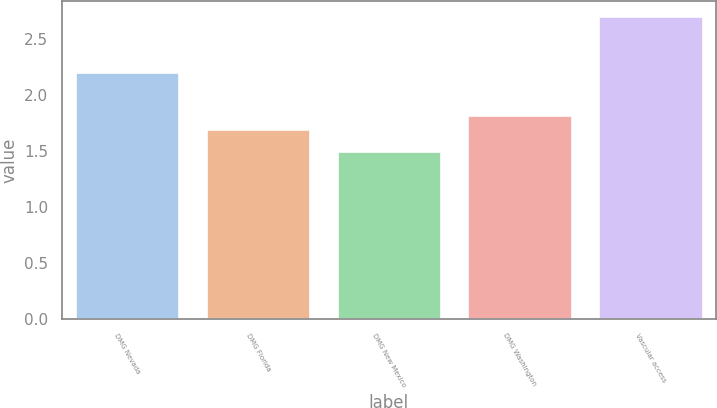<chart> <loc_0><loc_0><loc_500><loc_500><bar_chart><fcel>DMG Nevada<fcel>DMG Florida<fcel>DMG New Mexico<fcel>DMG Washington<fcel>Vascular access<nl><fcel>2.2<fcel>1.7<fcel>1.5<fcel>1.82<fcel>2.7<nl></chart> 